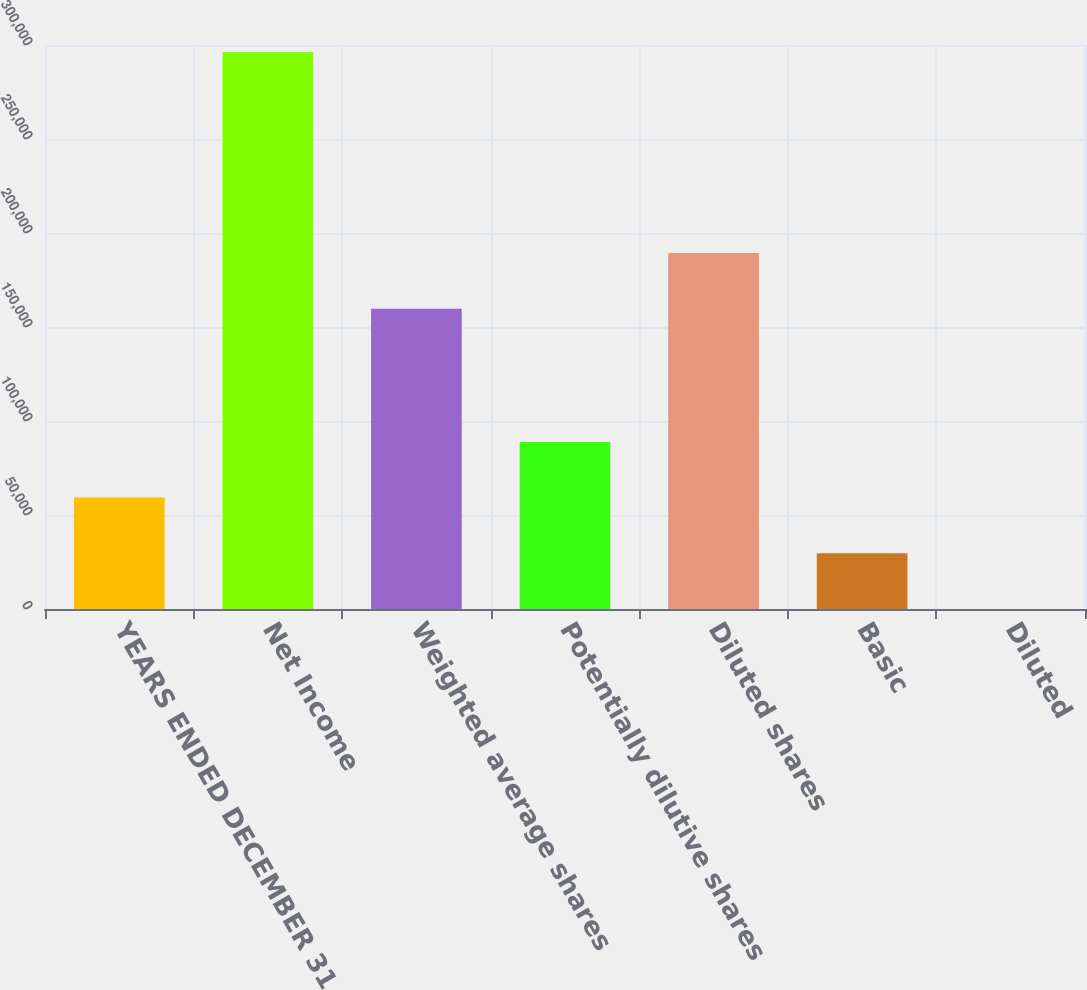<chart> <loc_0><loc_0><loc_500><loc_500><bar_chart><fcel>YEARS ENDED DECEMBER 31<fcel>Net Income<fcel>Weighted average shares<fcel>Potentially dilutive shares<fcel>Diluted shares<fcel>Basic<fcel>Diluted<nl><fcel>59243.8<fcel>296212<fcel>159767<fcel>88864.9<fcel>189388<fcel>29622.8<fcel>1.81<nl></chart> 